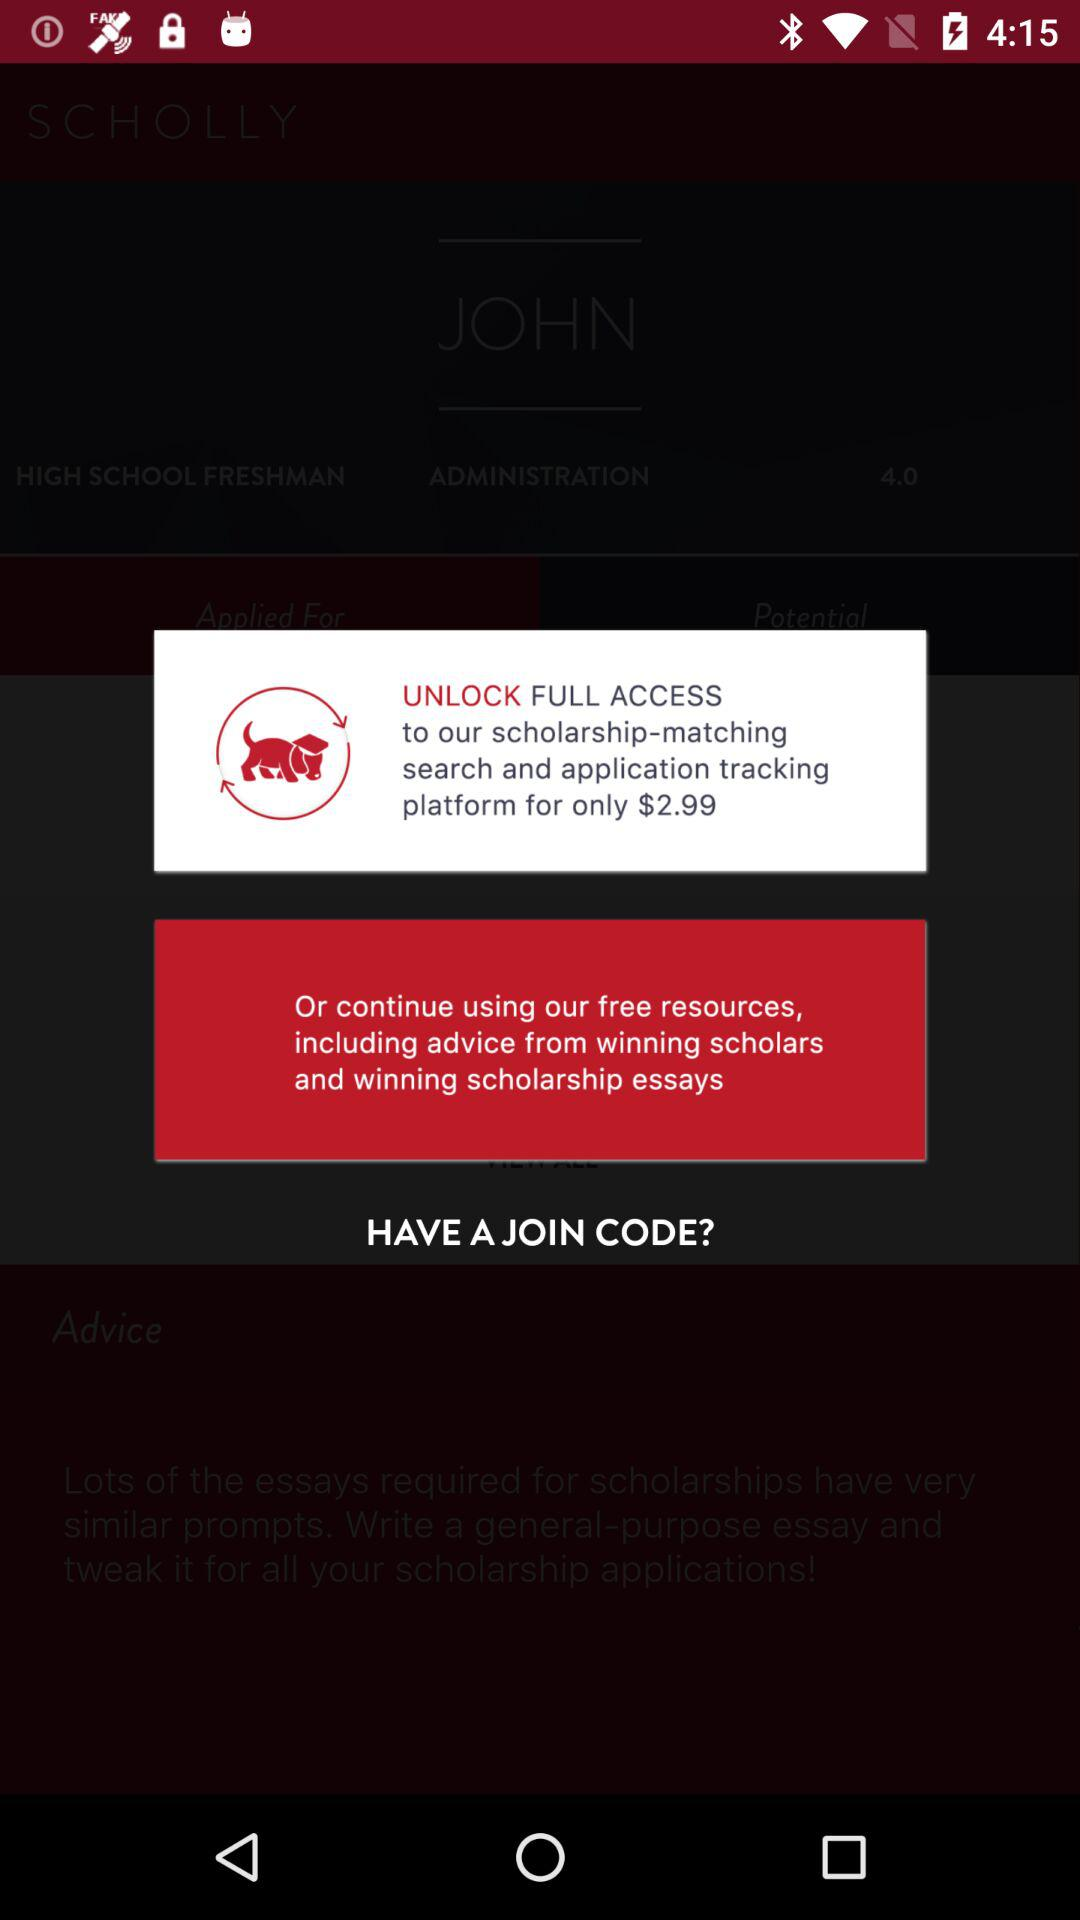How much more do you have to pay for full access than for the free resources?
Answer the question using a single word or phrase. $2.99 